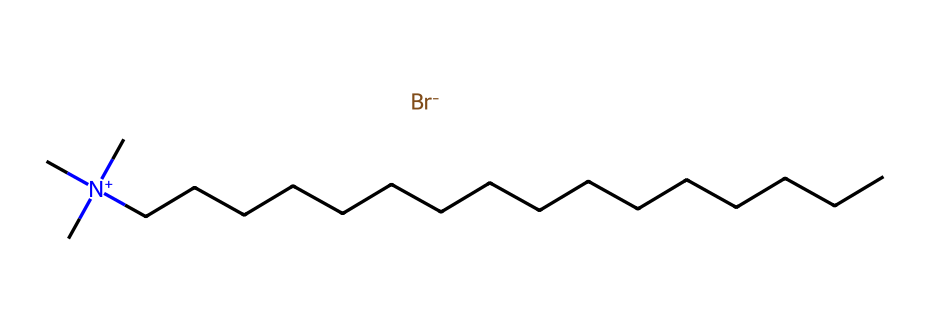What is the total number of carbon atoms in cetrimonium bromide? By examining the SMILES representation, we count the 'C' characters. There are 16 carbon atoms in the long hydrocarbon tail.
Answer: 16 What is the charge of the nitrogen atom in cetrimonium bromide? The SMILES structure shows a nitrogen atom with a positive charge indicated by the '[N+]'. This indicates that the nitrogen has a positive charge.
Answer: positive How many hydrogen atoms are attached to nitrogen in cetrimonium bromide? In the SMILES, nitrogen is represented as '[N+](C)(C)C', indicating it is bonded to three carbon atoms (which are connected to hydrogen atoms), and the nitrogen atom typically has one implicit hydrogen attached when its bonds are considered.
Answer: 1 What type of functional group is present in cetrimonium bromide? The positive nitrogen atom and the bromide ion indicate that this is a quaternary ammonium compound, which features a positively charged nitrogen. This is characteristic of surfactants.
Answer: quaternary ammonium What is the role of cetrimonium bromide in hair conditioners? Cetrimonium bromide, being a surfactant, helps in reducing surface tension, allowing for better spreading and detangling of hair, thus enhancing conditioning properties.
Answer: conditioning agent What does the bromide part of cetrimonium bromide represent? The bromide ion '[Br-]' represents the counter ion that balances the positive charge of the nitrogen, making the compound neutral overall. This is typical in quaternary ammonium salts.
Answer: counter ion 